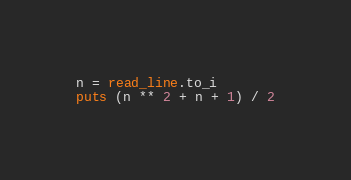Convert code to text. <code><loc_0><loc_0><loc_500><loc_500><_Crystal_>n = read_line.to_i
puts (n ** 2 + n + 1) / 2</code> 